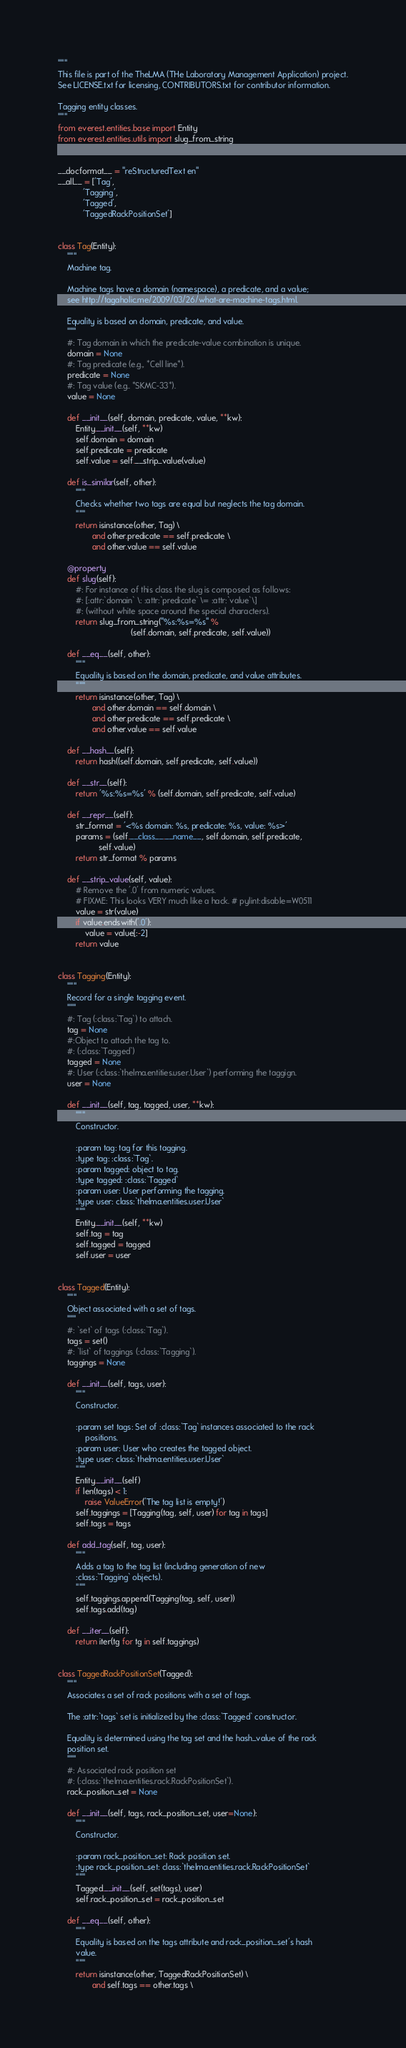<code> <loc_0><loc_0><loc_500><loc_500><_Python_>"""
This file is part of the TheLMA (THe Laboratory Management Application) project.
See LICENSE.txt for licensing, CONTRIBUTORS.txt for contributor information.

Tagging entity classes.
"""
from everest.entities.base import Entity
from everest.entities.utils import slug_from_string


__docformat__ = "reStructuredText en"
__all__ = ['Tag',
           'Tagging',
           'Tagged',
           'TaggedRackPositionSet']


class Tag(Entity):
    """
    Machine tag.

    Machine tags have a domain (namespace), a predicate, and a value;
    see http://tagaholic.me/2009/03/26/what-are-machine-tags.html.

    Equality is based on domain, predicate, and value.
    """
    #: Tag domain in which the predicate-value combination is unique.
    domain = None
    #: Tag predicate (e.g., *Cell line*).
    predicate = None
    #: Tag value (e.g.. *SKMC-33*).
    value = None

    def __init__(self, domain, predicate, value, **kw):
        Entity.__init__(self, **kw)
        self.domain = domain
        self.predicate = predicate
        self.value = self.__strip_value(value)

    def is_similar(self, other):
        """
        Checks whether two tags are equal but neglects the tag domain.
        """
        return isinstance(other, Tag) \
               and other.predicate == self.predicate \
               and other.value == self.value

    @property
    def slug(self):
        #: For instance of this class the slug is composed as follows:
        #: [:attr:`domain` \: :attr:`predicate` \= :attr:`value`\]
        #: (without white space around the special characters).
        return slug_from_string("%s:%s=%s" %
                                (self.domain, self.predicate, self.value))

    def __eq__(self, other):
        """
        Equality is based on the domain, predicate, and value attributes.
        """
        return isinstance(other, Tag) \
               and other.domain == self.domain \
               and other.predicate == self.predicate \
               and other.value == self.value

    def __hash__(self):
        return hash((self.domain, self.predicate, self.value))

    def __str__(self):
        return '%s:%s=%s' % (self.domain, self.predicate, self.value)

    def __repr__(self):
        str_format = '<%s domain: %s, predicate: %s, value: %s>'
        params = (self.__class__.__name__, self.domain, self.predicate,
                  self.value)
        return str_format % params

    def __strip_value(self, value):
        # Remove the '.0' from numeric values.
        # FIXME: This looks VERY much like a hack. # pylint:disable=W0511
        value = str(value)
        if value.endswith('.0'):
            value = value[:-2]
        return value


class Tagging(Entity):
    """
    Record for a single tagging event.
    """
    #: Tag (:class:`Tag`) to attach.
    tag = None
    #:Object to attach the tag to.
    #: (:class:`Tagged`)
    tagged = None
    #: User (:class:`thelma.entities.user.User`) performing the taggign.
    user = None

    def __init__(self, tag, tagged, user, **kw):
        """
        Constructor.

        :param tag: tag for this tagging.
        :type tag: :class:`Tag`.
        :param tagged: object to tag.
        :type tagged: :class:`Tagged`
        :param user: User performing the tagging.
        :type user: class:`thelma.entities.user.User`
        """
        Entity.__init__(self, **kw)
        self.tag = tag
        self.tagged = tagged
        self.user = user


class Tagged(Entity):
    """
    Object associated with a set of tags.
    """
    #: `set` of tags (:class:`Tag`).
    tags = set()
    #: `list` of taggings (:class:`Tagging`).
    taggings = None

    def __init__(self, tags, user):
        """
        Constructor.

        :param set tags: Set of :class:`Tag` instances associated to the rack
            positions.
        :param user: User who creates the tagged object.
        :type user: class:`thelma.entities.user.User`
        """
        Entity.__init__(self)
        if len(tags) < 1:
            raise ValueError('The tag list is empty!')
        self.taggings = [Tagging(tag, self, user) for tag in tags]
        self.tags = tags

    def add_tag(self, tag, user):
        """
        Adds a tag to the tag list (including generation of new
        :class:`Tagging` objects).
        """
        self.taggings.append(Tagging(tag, self, user))
        self.tags.add(tag)

    def __iter__(self):
        return iter(tg for tg in self.taggings)


class TaggedRackPositionSet(Tagged):
    """
    Associates a set of rack positions with a set of tags.

    The :attr:`tags` set is initialized by the :class:`Tagged` constructor.

    Equality is determined using the tag set and the hash_value of the rack
    position set.
    """
    #: Associated rack position set
    #: (:class:`thelma.entities.rack.RackPositionSet`).
    rack_position_set = None

    def __init__(self, tags, rack_position_set, user=None):
        """
        Constructor.

        :param rack_position_set: Rack position set.
        :type rack_position_set: class:`thelma.entities.rack.RackPositionSet`
        """
        Tagged.__init__(self, set(tags), user)
        self.rack_position_set = rack_position_set

    def __eq__(self, other):
        """
        Equality is based on the tags attribute and rack_position_set's hash
        value.
        """
        return isinstance(other, TaggedRackPositionSet) \
               and self.tags == other.tags \</code> 